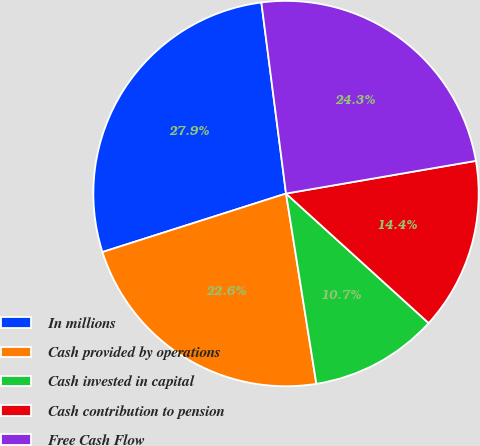Convert chart. <chart><loc_0><loc_0><loc_500><loc_500><pie_chart><fcel>In millions<fcel>Cash provided by operations<fcel>Cash invested in capital<fcel>Cash contribution to pension<fcel>Free Cash Flow<nl><fcel>27.87%<fcel>22.61%<fcel>10.75%<fcel>14.45%<fcel>24.33%<nl></chart> 